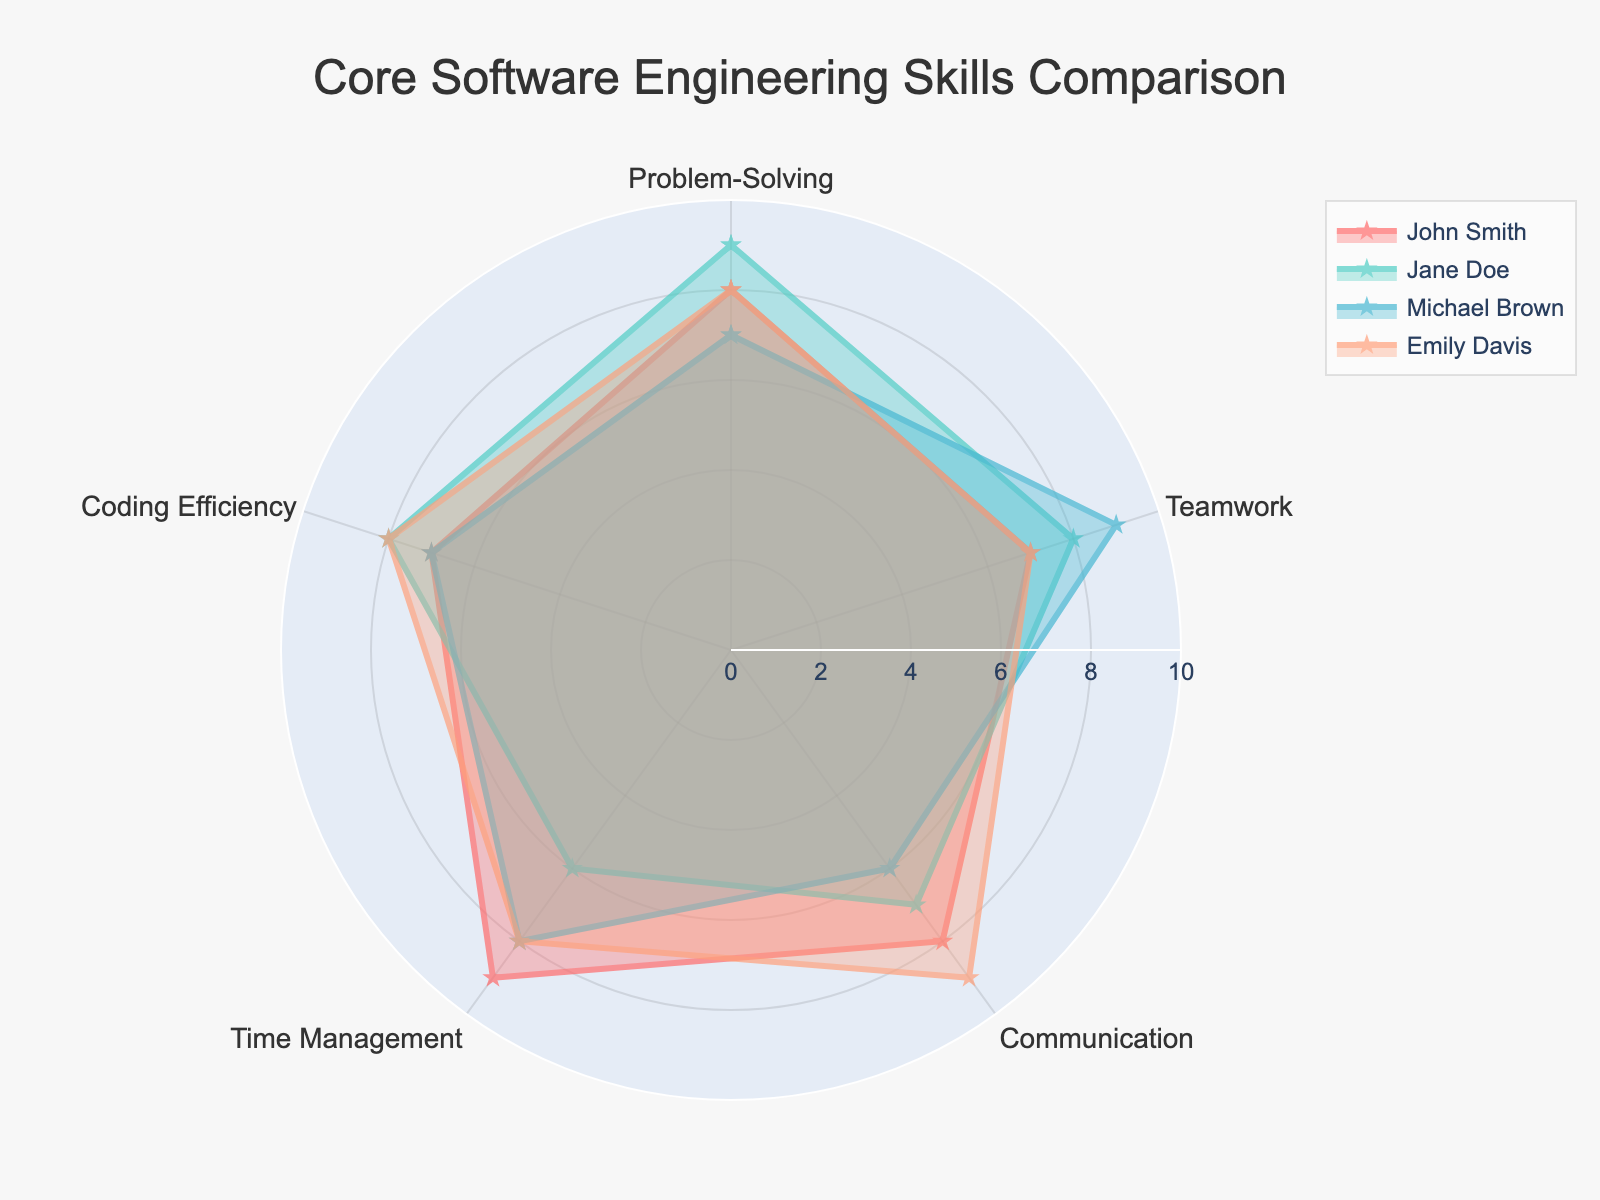What is the title of the chart? The title is located at the top of the chart and typically describes the overall subject or focus.
Answer: Core Software Engineering Skills Comparison How many categories are evaluated in the chart? The categories are listed around the outer edge of the radar chart, and you can count them directly from this area.
Answer: 5 Which individual has the highest rating for Problem-Solving? Look at the Problem-Solving axis and compare the ratings of John, Jane, Michael, and Emily. The highest rating corresponds to Jane with a score of 9.
Answer: Jane Doe Who has the lowest score for Communication? Examine the Communication axis and compare the values. Michael Brown has the lowest score, which is 6.
Answer: Michael Brown What is the average rating for Time Management across all individuals? Add all the Time Management scores and divide by the number of individuals. The sums are 9 (John), 6 (Jane), 8 (Michael), and 8 (Emily), making the total 31. Divide by 4 to find the average.
Answer: 7.75 Who has the most balanced skills profile, with the least variation between categories? Look at the plotted lines for each individual and compare the consistency of their scores across the categories. Emily Davis shows a very balanced profile as her scores in each category are relatively close to each other (all in the range of 7-9).
Answer: Emily Davis Which two individuals show the most significant difference in Teamwork scores? Compare the Teamwork scores directly. John Smith and Michael Brown have scores of 7 and 9, respectively, creating a difference of 2 points, which is the largest among the comparisons.
Answer: John Smith and Michael Brown In which skill category do John Smith and Emily Davis have the same score? Check each category and find where John and Emily have matching values. Both have a score of 8 in the Problem-Solving category.
Answer: Problem-Solving What is the total score for coding efficiency for all individuals combined? Add the Coding Efficiency scores of all individuals: John (7) + Jane (8) + Michael (7) + Emily (8). The total is 30.
Answer: 30 Which individual ranks highest overall when summing scores across all categories? Calculate the sum of each individual's scores across all categories: John (39), Jane (38), Michael (37), and Emily (40). Emily Davis has the highest total score.
Answer: Emily Davis 